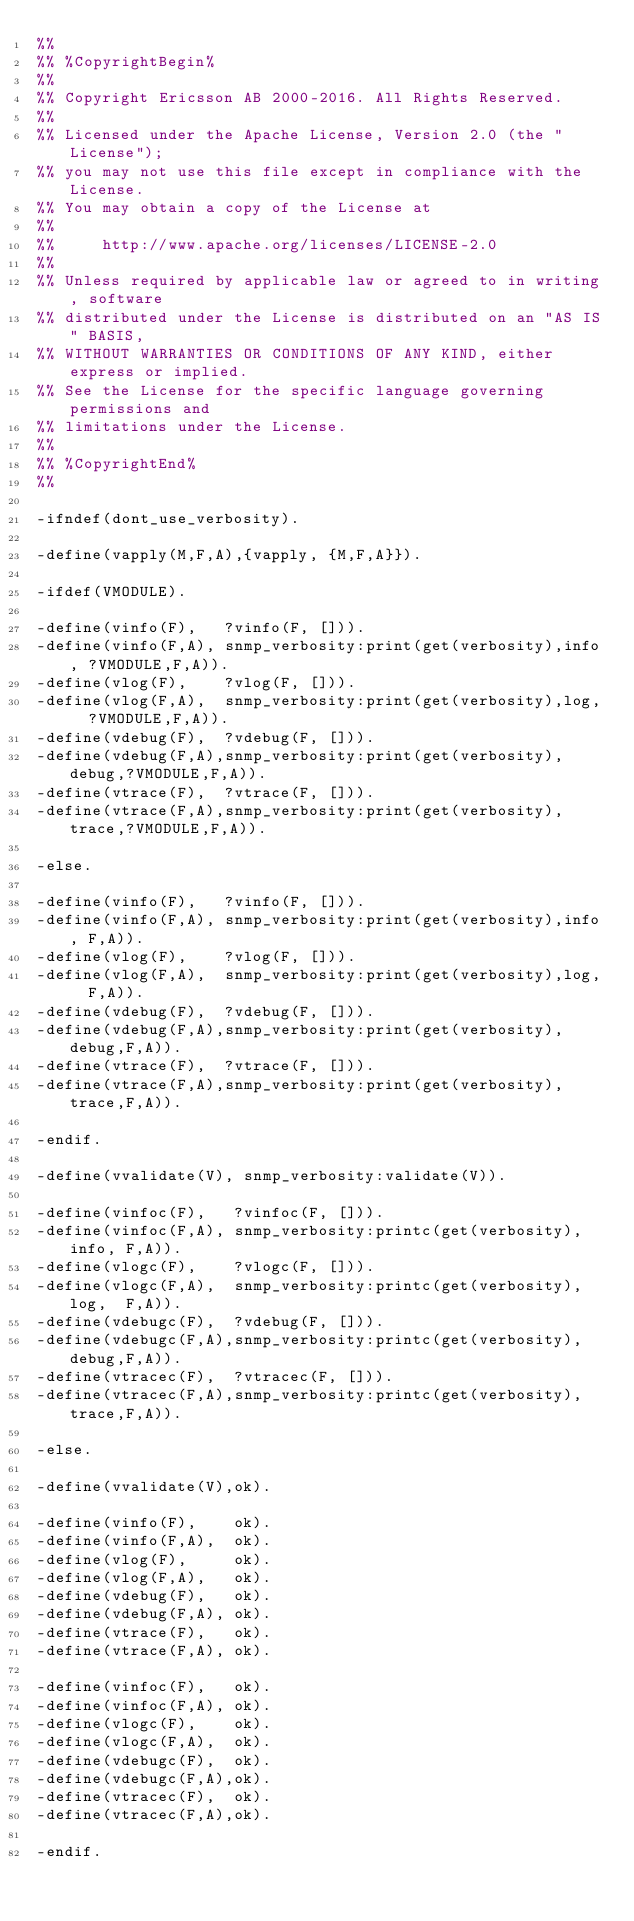<code> <loc_0><loc_0><loc_500><loc_500><_Erlang_>%% 
%% %CopyrightBegin%
%% 
%% Copyright Ericsson AB 2000-2016. All Rights Reserved.
%% 
%% Licensed under the Apache License, Version 2.0 (the "License");
%% you may not use this file except in compliance with the License.
%% You may obtain a copy of the License at
%%
%%     http://www.apache.org/licenses/LICENSE-2.0
%%
%% Unless required by applicable law or agreed to in writing, software
%% distributed under the License is distributed on an "AS IS" BASIS,
%% WITHOUT WARRANTIES OR CONDITIONS OF ANY KIND, either express or implied.
%% See the License for the specific language governing permissions and
%% limitations under the License.
%% 
%% %CopyrightEnd%
%% 

-ifndef(dont_use_verbosity).

-define(vapply(M,F,A),{vapply, {M,F,A}}).

-ifdef(VMODULE).

-define(vinfo(F),   ?vinfo(F, [])).
-define(vinfo(F,A), snmp_verbosity:print(get(verbosity),info, ?VMODULE,F,A)).
-define(vlog(F),    ?vlog(F, [])).
-define(vlog(F,A),  snmp_verbosity:print(get(verbosity),log,  ?VMODULE,F,A)).
-define(vdebug(F),  ?vdebug(F, [])).
-define(vdebug(F,A),snmp_verbosity:print(get(verbosity),debug,?VMODULE,F,A)).
-define(vtrace(F),  ?vtrace(F, [])).
-define(vtrace(F,A),snmp_verbosity:print(get(verbosity),trace,?VMODULE,F,A)).

-else.

-define(vinfo(F),   ?vinfo(F, [])).
-define(vinfo(F,A), snmp_verbosity:print(get(verbosity),info, F,A)).
-define(vlog(F),    ?vlog(F, [])).
-define(vlog(F,A),  snmp_verbosity:print(get(verbosity),log,  F,A)).
-define(vdebug(F),  ?vdebug(F, [])).
-define(vdebug(F,A),snmp_verbosity:print(get(verbosity),debug,F,A)).
-define(vtrace(F),  ?vtrace(F, [])).
-define(vtrace(F,A),snmp_verbosity:print(get(verbosity),trace,F,A)).

-endif.

-define(vvalidate(V), snmp_verbosity:validate(V)).

-define(vinfoc(F),   ?vinfoc(F, [])).
-define(vinfoc(F,A), snmp_verbosity:printc(get(verbosity),info, F,A)).
-define(vlogc(F),    ?vlogc(F, [])).
-define(vlogc(F,A),  snmp_verbosity:printc(get(verbosity),log,  F,A)).
-define(vdebugc(F),  ?vdebug(F, [])).
-define(vdebugc(F,A),snmp_verbosity:printc(get(verbosity),debug,F,A)).
-define(vtracec(F),  ?vtracec(F, [])).
-define(vtracec(F,A),snmp_verbosity:printc(get(verbosity),trace,F,A)).

-else.

-define(vvalidate(V),ok).

-define(vinfo(F),    ok).
-define(vinfo(F,A),  ok).
-define(vlog(F),     ok).
-define(vlog(F,A),   ok).
-define(vdebug(F),   ok).
-define(vdebug(F,A), ok).
-define(vtrace(F),   ok).
-define(vtrace(F,A), ok).

-define(vinfoc(F),   ok).
-define(vinfoc(F,A), ok).
-define(vlogc(F),    ok).
-define(vlogc(F,A),  ok).
-define(vdebugc(F),  ok).
-define(vdebugc(F,A),ok).
-define(vtracec(F),  ok).
-define(vtracec(F,A),ok).

-endif.



</code> 